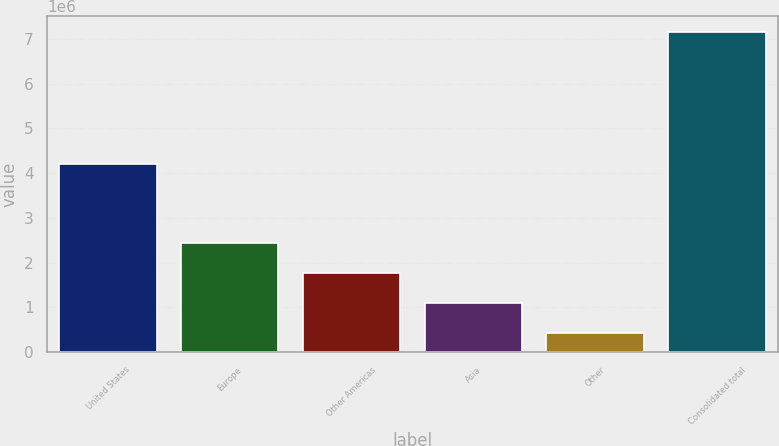<chart> <loc_0><loc_0><loc_500><loc_500><bar_chart><fcel>United States<fcel>Europe<fcel>Other Americas<fcel>Asia<fcel>Other<fcel>Consolidated total<nl><fcel>4.20243e+06<fcel>2.44667e+06<fcel>1.77403e+06<fcel>1.1014e+06<fcel>428769<fcel>7.1551e+06<nl></chart> 